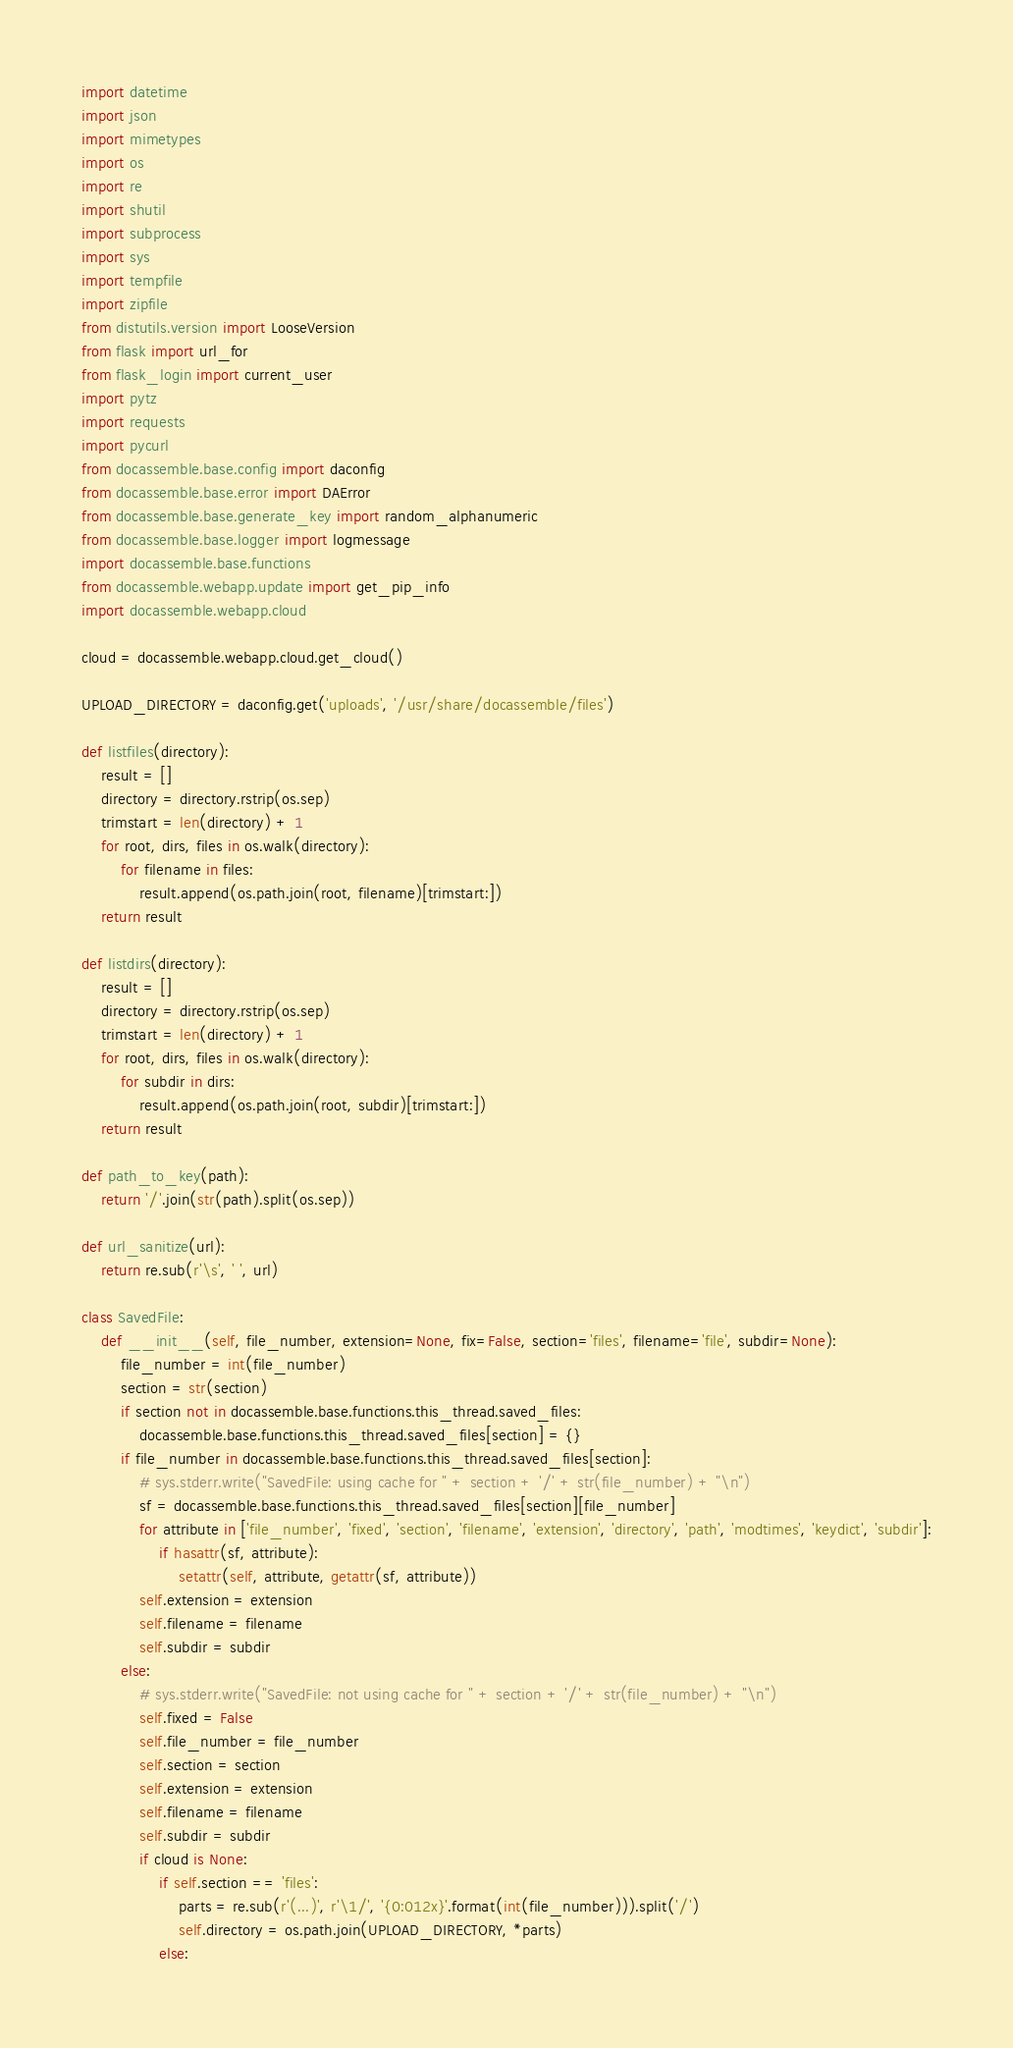Convert code to text. <code><loc_0><loc_0><loc_500><loc_500><_Python_>import datetime
import json
import mimetypes
import os
import re
import shutil
import subprocess
import sys
import tempfile
import zipfile
from distutils.version import LooseVersion
from flask import url_for
from flask_login import current_user
import pytz
import requests
import pycurl
from docassemble.base.config import daconfig
from docassemble.base.error import DAError
from docassemble.base.generate_key import random_alphanumeric
from docassemble.base.logger import logmessage
import docassemble.base.functions
from docassemble.webapp.update import get_pip_info
import docassemble.webapp.cloud

cloud = docassemble.webapp.cloud.get_cloud()

UPLOAD_DIRECTORY = daconfig.get('uploads', '/usr/share/docassemble/files')

def listfiles(directory):
    result = []
    directory = directory.rstrip(os.sep)
    trimstart = len(directory) + 1
    for root, dirs, files in os.walk(directory):
        for filename in files:
            result.append(os.path.join(root, filename)[trimstart:])
    return result

def listdirs(directory):
    result = []
    directory = directory.rstrip(os.sep)
    trimstart = len(directory) + 1
    for root, dirs, files in os.walk(directory):
        for subdir in dirs:
            result.append(os.path.join(root, subdir)[trimstart:])
    return result

def path_to_key(path):
    return '/'.join(str(path).split(os.sep))

def url_sanitize(url):
    return re.sub(r'\s', ' ', url)

class SavedFile:
    def __init__(self, file_number, extension=None, fix=False, section='files', filename='file', subdir=None):
        file_number = int(file_number)
        section = str(section)
        if section not in docassemble.base.functions.this_thread.saved_files:
            docassemble.base.functions.this_thread.saved_files[section] = {}
        if file_number in docassemble.base.functions.this_thread.saved_files[section]:
            # sys.stderr.write("SavedFile: using cache for " + section + '/' + str(file_number) + "\n")
            sf = docassemble.base.functions.this_thread.saved_files[section][file_number]
            for attribute in ['file_number', 'fixed', 'section', 'filename', 'extension', 'directory', 'path', 'modtimes', 'keydict', 'subdir']:
                if hasattr(sf, attribute):
                    setattr(self, attribute, getattr(sf, attribute))
            self.extension = extension
            self.filename = filename
            self.subdir = subdir
        else:
            # sys.stderr.write("SavedFile: not using cache for " + section + '/' + str(file_number) + "\n")
            self.fixed = False
            self.file_number = file_number
            self.section = section
            self.extension = extension
            self.filename = filename
            self.subdir = subdir
            if cloud is None:
                if self.section == 'files':
                    parts = re.sub(r'(...)', r'\1/', '{0:012x}'.format(int(file_number))).split('/')
                    self.directory = os.path.join(UPLOAD_DIRECTORY, *parts)
                else:</code> 